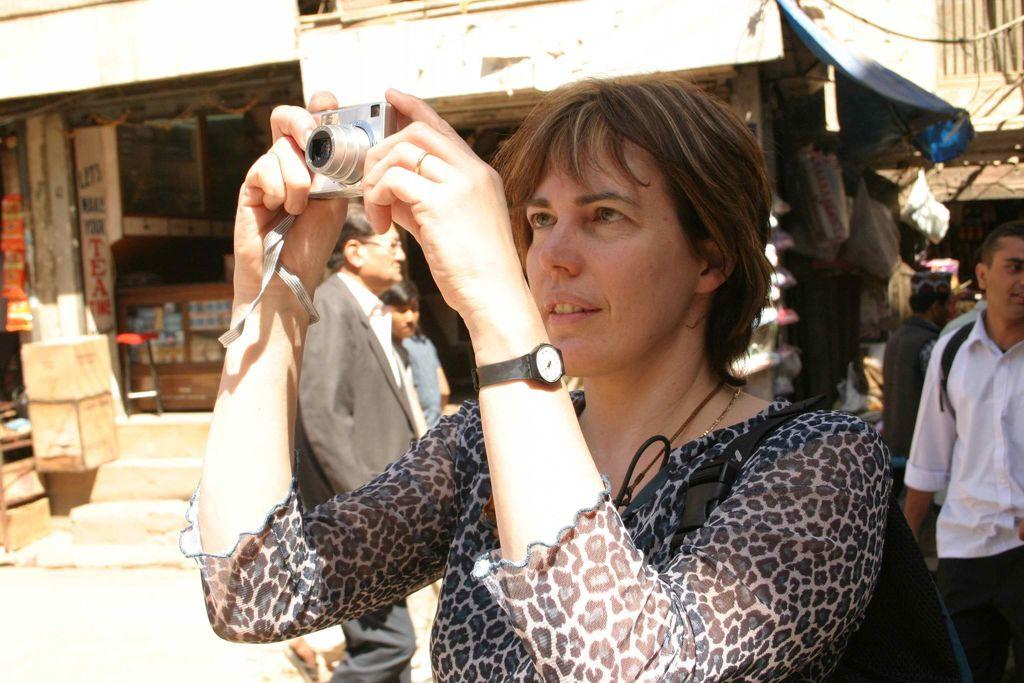Who is the main subject in the image? There is a woman in the image. What is the woman doing in the image? The woman is standing in the image. What object is the woman holding in her hand? The woman is holding a camera in her hand. Can you describe the background of the image? There are people standing in the background of the image. What type of brake can be seen on the desk in the image? There is no brake or desk present in the image. How many bikes are visible in the image? There are no bikes visible in the image. 